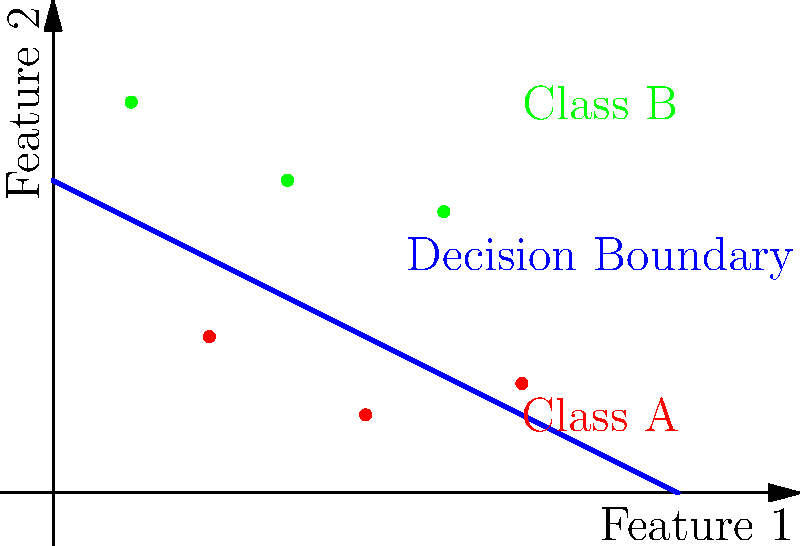In the context of job market analysis, you're working on a machine learning model to classify job seekers based on two features: years of experience (Feature 1) and skills proficiency (Feature 2). The scatter plot shows the decision boundary of a linear classifier. Which of the following statements is true about a new data point at coordinates (2.5, 1.5)? To determine the classification of the new data point, we need to follow these steps:

1. Understand the decision boundary:
   The blue line represents the decision boundary, which separates Class A (red points) from Class B (green points).

2. Interpret the decision rule:
   Points above the line are classified as Class B (green), while points below the line are classified as Class A (red).

3. Locate the new data point:
   The new point is at coordinates (2.5, 1.5).

4. Determine the equation of the decision boundary:
   The line can be described by the equation $y = -0.5x + 2$.

5. Evaluate the point's position relative to the boundary:
   - At $x = 2.5$, the y-value on the boundary line is:
     $y = -0.5(2.5) + 2 = 0.75$
   - The actual y-value of our point (1.5) is greater than 0.75.

6. Conclude the classification:
   Since the point (2.5, 1.5) lies above the decision boundary, it would be classified as Class B (green).

In the context of job market analysis, this could indicate that the job seeker with 2.5 years of experience and a skill proficiency of 1.5 would be classified in the higher-skilled or more suitable category for certain job opportunities.
Answer: Class B (higher-skilled category) 